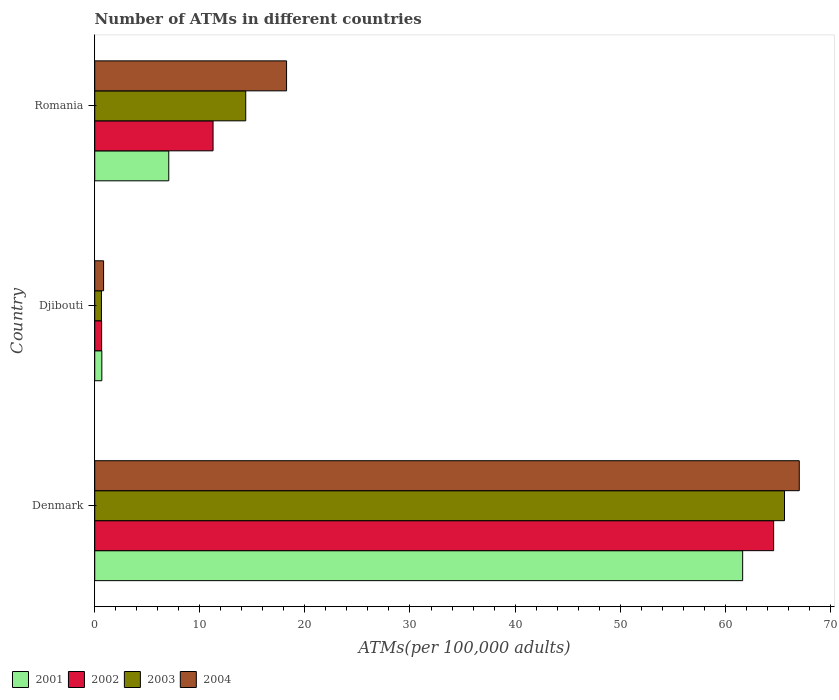Are the number of bars per tick equal to the number of legend labels?
Ensure brevity in your answer.  Yes. How many bars are there on the 3rd tick from the top?
Give a very brief answer. 4. How many bars are there on the 1st tick from the bottom?
Give a very brief answer. 4. What is the label of the 1st group of bars from the top?
Provide a succinct answer. Romania. What is the number of ATMs in 2004 in Djibouti?
Your answer should be very brief. 0.84. Across all countries, what is the maximum number of ATMs in 2004?
Your answer should be very brief. 67.04. Across all countries, what is the minimum number of ATMs in 2004?
Ensure brevity in your answer.  0.84. In which country was the number of ATMs in 2002 maximum?
Your answer should be very brief. Denmark. In which country was the number of ATMs in 2001 minimum?
Offer a terse response. Djibouti. What is the total number of ATMs in 2001 in the graph?
Keep it short and to the point. 69.38. What is the difference between the number of ATMs in 2003 in Denmark and that in Romania?
Keep it short and to the point. 51.27. What is the difference between the number of ATMs in 2002 in Romania and the number of ATMs in 2001 in Denmark?
Your answer should be compact. -50.4. What is the average number of ATMs in 2003 per country?
Offer a very short reply. 26.88. What is the difference between the number of ATMs in 2002 and number of ATMs in 2001 in Romania?
Make the answer very short. 4.21. What is the ratio of the number of ATMs in 2003 in Denmark to that in Romania?
Your answer should be very brief. 4.57. Is the number of ATMs in 2001 in Denmark less than that in Romania?
Provide a short and direct response. No. What is the difference between the highest and the second highest number of ATMs in 2004?
Your response must be concise. 48.79. What is the difference between the highest and the lowest number of ATMs in 2001?
Provide a short and direct response. 60.98. Is the sum of the number of ATMs in 2002 in Denmark and Djibouti greater than the maximum number of ATMs in 2004 across all countries?
Ensure brevity in your answer.  No. What does the 3rd bar from the bottom in Djibouti represents?
Ensure brevity in your answer.  2003. Are all the bars in the graph horizontal?
Offer a terse response. Yes. Does the graph contain any zero values?
Give a very brief answer. No. Does the graph contain grids?
Offer a very short reply. No. How many legend labels are there?
Make the answer very short. 4. What is the title of the graph?
Provide a short and direct response. Number of ATMs in different countries. What is the label or title of the X-axis?
Provide a succinct answer. ATMs(per 100,0 adults). What is the label or title of the Y-axis?
Give a very brief answer. Country. What is the ATMs(per 100,000 adults) in 2001 in Denmark?
Your answer should be compact. 61.66. What is the ATMs(per 100,000 adults) of 2002 in Denmark?
Your answer should be very brief. 64.61. What is the ATMs(per 100,000 adults) in 2003 in Denmark?
Provide a short and direct response. 65.64. What is the ATMs(per 100,000 adults) of 2004 in Denmark?
Offer a terse response. 67.04. What is the ATMs(per 100,000 adults) of 2001 in Djibouti?
Give a very brief answer. 0.68. What is the ATMs(per 100,000 adults) of 2002 in Djibouti?
Your response must be concise. 0.66. What is the ATMs(per 100,000 adults) of 2003 in Djibouti?
Keep it short and to the point. 0.64. What is the ATMs(per 100,000 adults) of 2004 in Djibouti?
Keep it short and to the point. 0.84. What is the ATMs(per 100,000 adults) in 2001 in Romania?
Your answer should be compact. 7.04. What is the ATMs(per 100,000 adults) in 2002 in Romania?
Ensure brevity in your answer.  11.26. What is the ATMs(per 100,000 adults) in 2003 in Romania?
Give a very brief answer. 14.37. What is the ATMs(per 100,000 adults) of 2004 in Romania?
Offer a very short reply. 18.26. Across all countries, what is the maximum ATMs(per 100,000 adults) in 2001?
Give a very brief answer. 61.66. Across all countries, what is the maximum ATMs(per 100,000 adults) of 2002?
Your answer should be compact. 64.61. Across all countries, what is the maximum ATMs(per 100,000 adults) in 2003?
Provide a short and direct response. 65.64. Across all countries, what is the maximum ATMs(per 100,000 adults) in 2004?
Your answer should be compact. 67.04. Across all countries, what is the minimum ATMs(per 100,000 adults) of 2001?
Offer a terse response. 0.68. Across all countries, what is the minimum ATMs(per 100,000 adults) of 2002?
Your answer should be very brief. 0.66. Across all countries, what is the minimum ATMs(per 100,000 adults) in 2003?
Provide a short and direct response. 0.64. Across all countries, what is the minimum ATMs(per 100,000 adults) of 2004?
Provide a succinct answer. 0.84. What is the total ATMs(per 100,000 adults) of 2001 in the graph?
Provide a short and direct response. 69.38. What is the total ATMs(per 100,000 adults) in 2002 in the graph?
Provide a short and direct response. 76.52. What is the total ATMs(per 100,000 adults) of 2003 in the graph?
Your answer should be compact. 80.65. What is the total ATMs(per 100,000 adults) in 2004 in the graph?
Give a very brief answer. 86.14. What is the difference between the ATMs(per 100,000 adults) in 2001 in Denmark and that in Djibouti?
Ensure brevity in your answer.  60.98. What is the difference between the ATMs(per 100,000 adults) of 2002 in Denmark and that in Djibouti?
Keep it short and to the point. 63.95. What is the difference between the ATMs(per 100,000 adults) in 2003 in Denmark and that in Djibouti?
Provide a short and direct response. 65. What is the difference between the ATMs(per 100,000 adults) in 2004 in Denmark and that in Djibouti?
Provide a short and direct response. 66.2. What is the difference between the ATMs(per 100,000 adults) of 2001 in Denmark and that in Romania?
Your answer should be very brief. 54.61. What is the difference between the ATMs(per 100,000 adults) of 2002 in Denmark and that in Romania?
Your answer should be very brief. 53.35. What is the difference between the ATMs(per 100,000 adults) of 2003 in Denmark and that in Romania?
Keep it short and to the point. 51.27. What is the difference between the ATMs(per 100,000 adults) in 2004 in Denmark and that in Romania?
Provide a succinct answer. 48.79. What is the difference between the ATMs(per 100,000 adults) of 2001 in Djibouti and that in Romania?
Keep it short and to the point. -6.37. What is the difference between the ATMs(per 100,000 adults) of 2002 in Djibouti and that in Romania?
Offer a very short reply. -10.6. What is the difference between the ATMs(per 100,000 adults) of 2003 in Djibouti and that in Romania?
Your answer should be very brief. -13.73. What is the difference between the ATMs(per 100,000 adults) in 2004 in Djibouti and that in Romania?
Ensure brevity in your answer.  -17.41. What is the difference between the ATMs(per 100,000 adults) of 2001 in Denmark and the ATMs(per 100,000 adults) of 2002 in Djibouti?
Offer a very short reply. 61. What is the difference between the ATMs(per 100,000 adults) of 2001 in Denmark and the ATMs(per 100,000 adults) of 2003 in Djibouti?
Offer a very short reply. 61.02. What is the difference between the ATMs(per 100,000 adults) in 2001 in Denmark and the ATMs(per 100,000 adults) in 2004 in Djibouti?
Give a very brief answer. 60.81. What is the difference between the ATMs(per 100,000 adults) in 2002 in Denmark and the ATMs(per 100,000 adults) in 2003 in Djibouti?
Provide a succinct answer. 63.97. What is the difference between the ATMs(per 100,000 adults) in 2002 in Denmark and the ATMs(per 100,000 adults) in 2004 in Djibouti?
Provide a succinct answer. 63.76. What is the difference between the ATMs(per 100,000 adults) in 2003 in Denmark and the ATMs(per 100,000 adults) in 2004 in Djibouti?
Make the answer very short. 64.79. What is the difference between the ATMs(per 100,000 adults) in 2001 in Denmark and the ATMs(per 100,000 adults) in 2002 in Romania?
Provide a succinct answer. 50.4. What is the difference between the ATMs(per 100,000 adults) in 2001 in Denmark and the ATMs(per 100,000 adults) in 2003 in Romania?
Your answer should be compact. 47.29. What is the difference between the ATMs(per 100,000 adults) of 2001 in Denmark and the ATMs(per 100,000 adults) of 2004 in Romania?
Your answer should be very brief. 43.4. What is the difference between the ATMs(per 100,000 adults) of 2002 in Denmark and the ATMs(per 100,000 adults) of 2003 in Romania?
Your response must be concise. 50.24. What is the difference between the ATMs(per 100,000 adults) of 2002 in Denmark and the ATMs(per 100,000 adults) of 2004 in Romania?
Provide a short and direct response. 46.35. What is the difference between the ATMs(per 100,000 adults) in 2003 in Denmark and the ATMs(per 100,000 adults) in 2004 in Romania?
Keep it short and to the point. 47.38. What is the difference between the ATMs(per 100,000 adults) in 2001 in Djibouti and the ATMs(per 100,000 adults) in 2002 in Romania?
Ensure brevity in your answer.  -10.58. What is the difference between the ATMs(per 100,000 adults) in 2001 in Djibouti and the ATMs(per 100,000 adults) in 2003 in Romania?
Provide a succinct answer. -13.69. What is the difference between the ATMs(per 100,000 adults) of 2001 in Djibouti and the ATMs(per 100,000 adults) of 2004 in Romania?
Provide a short and direct response. -17.58. What is the difference between the ATMs(per 100,000 adults) in 2002 in Djibouti and the ATMs(per 100,000 adults) in 2003 in Romania?
Offer a terse response. -13.71. What is the difference between the ATMs(per 100,000 adults) of 2002 in Djibouti and the ATMs(per 100,000 adults) of 2004 in Romania?
Offer a terse response. -17.6. What is the difference between the ATMs(per 100,000 adults) of 2003 in Djibouti and the ATMs(per 100,000 adults) of 2004 in Romania?
Keep it short and to the point. -17.62. What is the average ATMs(per 100,000 adults) of 2001 per country?
Give a very brief answer. 23.13. What is the average ATMs(per 100,000 adults) in 2002 per country?
Keep it short and to the point. 25.51. What is the average ATMs(per 100,000 adults) of 2003 per country?
Your answer should be very brief. 26.88. What is the average ATMs(per 100,000 adults) of 2004 per country?
Keep it short and to the point. 28.71. What is the difference between the ATMs(per 100,000 adults) in 2001 and ATMs(per 100,000 adults) in 2002 in Denmark?
Your response must be concise. -2.95. What is the difference between the ATMs(per 100,000 adults) in 2001 and ATMs(per 100,000 adults) in 2003 in Denmark?
Make the answer very short. -3.98. What is the difference between the ATMs(per 100,000 adults) of 2001 and ATMs(per 100,000 adults) of 2004 in Denmark?
Make the answer very short. -5.39. What is the difference between the ATMs(per 100,000 adults) of 2002 and ATMs(per 100,000 adults) of 2003 in Denmark?
Ensure brevity in your answer.  -1.03. What is the difference between the ATMs(per 100,000 adults) in 2002 and ATMs(per 100,000 adults) in 2004 in Denmark?
Your answer should be very brief. -2.44. What is the difference between the ATMs(per 100,000 adults) of 2003 and ATMs(per 100,000 adults) of 2004 in Denmark?
Offer a terse response. -1.41. What is the difference between the ATMs(per 100,000 adults) of 2001 and ATMs(per 100,000 adults) of 2002 in Djibouti?
Offer a terse response. 0.02. What is the difference between the ATMs(per 100,000 adults) of 2001 and ATMs(per 100,000 adults) of 2003 in Djibouti?
Give a very brief answer. 0.04. What is the difference between the ATMs(per 100,000 adults) in 2001 and ATMs(per 100,000 adults) in 2004 in Djibouti?
Your answer should be very brief. -0.17. What is the difference between the ATMs(per 100,000 adults) of 2002 and ATMs(per 100,000 adults) of 2003 in Djibouti?
Your answer should be compact. 0.02. What is the difference between the ATMs(per 100,000 adults) in 2002 and ATMs(per 100,000 adults) in 2004 in Djibouti?
Your response must be concise. -0.19. What is the difference between the ATMs(per 100,000 adults) in 2003 and ATMs(per 100,000 adults) in 2004 in Djibouti?
Your response must be concise. -0.21. What is the difference between the ATMs(per 100,000 adults) in 2001 and ATMs(per 100,000 adults) in 2002 in Romania?
Your answer should be compact. -4.21. What is the difference between the ATMs(per 100,000 adults) of 2001 and ATMs(per 100,000 adults) of 2003 in Romania?
Your answer should be compact. -7.32. What is the difference between the ATMs(per 100,000 adults) in 2001 and ATMs(per 100,000 adults) in 2004 in Romania?
Offer a very short reply. -11.21. What is the difference between the ATMs(per 100,000 adults) of 2002 and ATMs(per 100,000 adults) of 2003 in Romania?
Make the answer very short. -3.11. What is the difference between the ATMs(per 100,000 adults) in 2002 and ATMs(per 100,000 adults) in 2004 in Romania?
Keep it short and to the point. -7. What is the difference between the ATMs(per 100,000 adults) of 2003 and ATMs(per 100,000 adults) of 2004 in Romania?
Keep it short and to the point. -3.89. What is the ratio of the ATMs(per 100,000 adults) of 2001 in Denmark to that in Djibouti?
Keep it short and to the point. 91.18. What is the ratio of the ATMs(per 100,000 adults) in 2002 in Denmark to that in Djibouti?
Keep it short and to the point. 98.45. What is the ratio of the ATMs(per 100,000 adults) of 2003 in Denmark to that in Djibouti?
Your response must be concise. 102.88. What is the ratio of the ATMs(per 100,000 adults) of 2004 in Denmark to that in Djibouti?
Provide a succinct answer. 79.46. What is the ratio of the ATMs(per 100,000 adults) in 2001 in Denmark to that in Romania?
Your answer should be compact. 8.75. What is the ratio of the ATMs(per 100,000 adults) of 2002 in Denmark to that in Romania?
Offer a very short reply. 5.74. What is the ratio of the ATMs(per 100,000 adults) in 2003 in Denmark to that in Romania?
Provide a succinct answer. 4.57. What is the ratio of the ATMs(per 100,000 adults) in 2004 in Denmark to that in Romania?
Your answer should be very brief. 3.67. What is the ratio of the ATMs(per 100,000 adults) of 2001 in Djibouti to that in Romania?
Make the answer very short. 0.1. What is the ratio of the ATMs(per 100,000 adults) in 2002 in Djibouti to that in Romania?
Your response must be concise. 0.06. What is the ratio of the ATMs(per 100,000 adults) in 2003 in Djibouti to that in Romania?
Your answer should be very brief. 0.04. What is the ratio of the ATMs(per 100,000 adults) of 2004 in Djibouti to that in Romania?
Ensure brevity in your answer.  0.05. What is the difference between the highest and the second highest ATMs(per 100,000 adults) of 2001?
Ensure brevity in your answer.  54.61. What is the difference between the highest and the second highest ATMs(per 100,000 adults) in 2002?
Provide a succinct answer. 53.35. What is the difference between the highest and the second highest ATMs(per 100,000 adults) of 2003?
Offer a very short reply. 51.27. What is the difference between the highest and the second highest ATMs(per 100,000 adults) of 2004?
Give a very brief answer. 48.79. What is the difference between the highest and the lowest ATMs(per 100,000 adults) in 2001?
Your response must be concise. 60.98. What is the difference between the highest and the lowest ATMs(per 100,000 adults) in 2002?
Offer a very short reply. 63.95. What is the difference between the highest and the lowest ATMs(per 100,000 adults) in 2003?
Provide a short and direct response. 65. What is the difference between the highest and the lowest ATMs(per 100,000 adults) in 2004?
Offer a terse response. 66.2. 